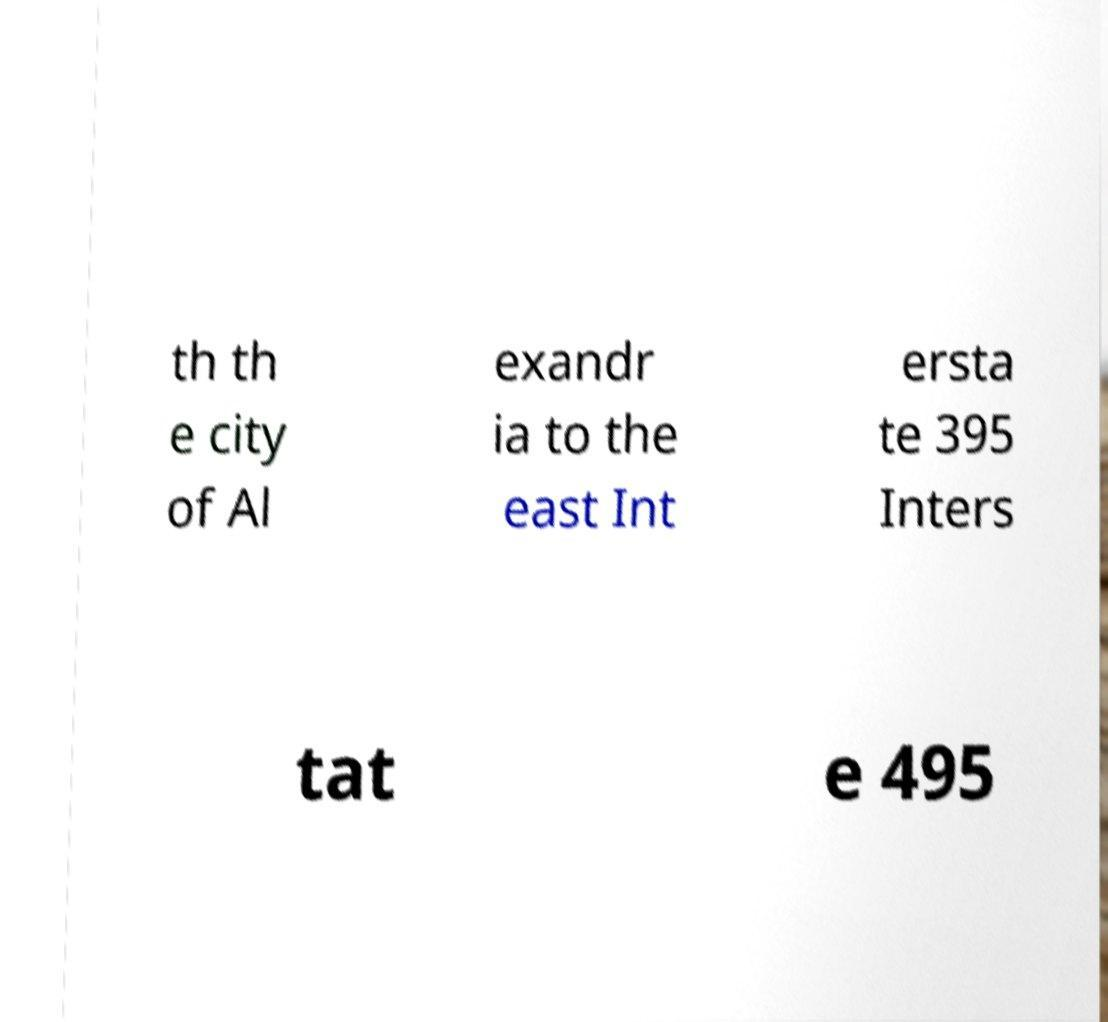Could you extract and type out the text from this image? th th e city of Al exandr ia to the east Int ersta te 395 Inters tat e 495 